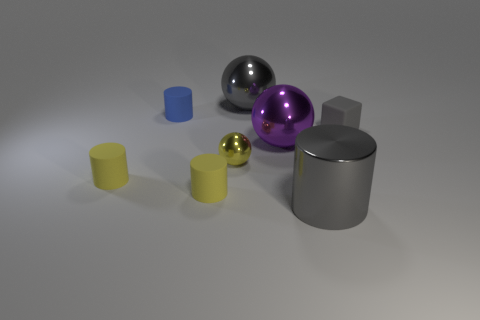Do the tiny cube and the metallic object behind the blue thing have the same color?
Your answer should be very brief. Yes. What number of blue objects are behind the large thing behind the big purple metal sphere?
Provide a succinct answer. 0. There is a matte thing right of the yellow cylinder to the right of the tiny blue object; what color is it?
Your answer should be very brief. Gray. The object that is right of the yellow sphere and behind the matte block is made of what material?
Ensure brevity in your answer.  Metal. Is there a big gray object of the same shape as the yellow shiny thing?
Give a very brief answer. Yes. There is a small yellow rubber thing left of the blue matte thing; does it have the same shape as the tiny blue object?
Offer a very short reply. Yes. How many gray things are both right of the purple shiny sphere and behind the yellow metal object?
Offer a very short reply. 1. There is a large gray thing that is in front of the small yellow shiny ball; what shape is it?
Ensure brevity in your answer.  Cylinder. What number of large gray things have the same material as the large gray sphere?
Make the answer very short. 1. Does the tiny yellow metallic object have the same shape as the gray object behind the rubber block?
Offer a very short reply. Yes. 